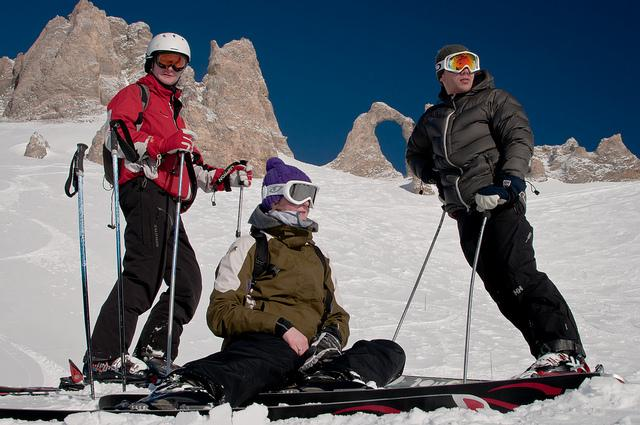What are the poles helping the man on the right do?

Choices:
A) stand
B) flip
C) spin
D) clean stand 